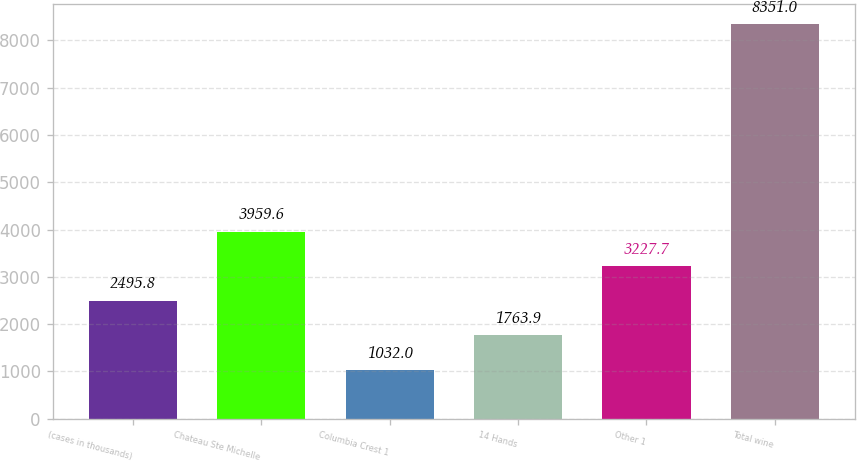Convert chart. <chart><loc_0><loc_0><loc_500><loc_500><bar_chart><fcel>(cases in thousands)<fcel>Chateau Ste Michelle<fcel>Columbia Crest 1<fcel>14 Hands<fcel>Other 1<fcel>Total wine<nl><fcel>2495.8<fcel>3959.6<fcel>1032<fcel>1763.9<fcel>3227.7<fcel>8351<nl></chart> 